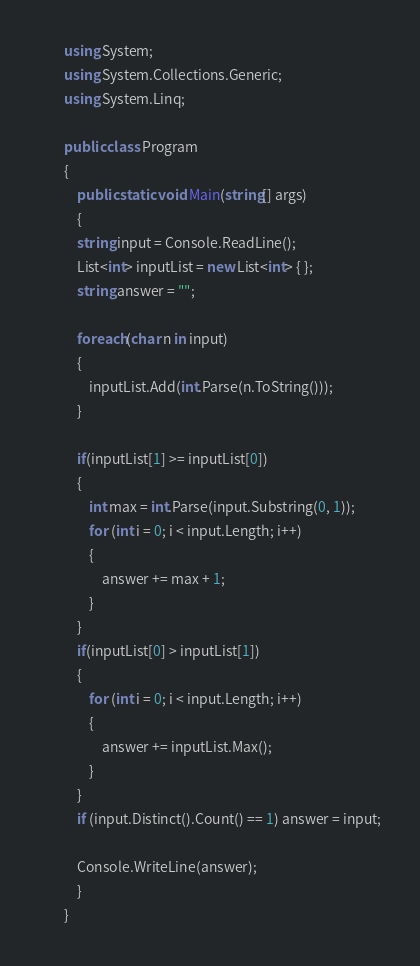Convert code to text. <code><loc_0><loc_0><loc_500><loc_500><_C#_>        using System;
        using System.Collections.Generic;
        using System.Linq;

        public class Program
        {
            public static void Main(string[] args)
            {
            string input = Console.ReadLine();
            List<int> inputList = new List<int> { };
            string answer = "";

            foreach(char n in input)
            {
                inputList.Add(int.Parse(n.ToString()));
            }

            if(inputList[1] >= inputList[0])
            {
                int max = int.Parse(input.Substring(0, 1));
                for (int i = 0; i < input.Length; i++)
                {
                    answer += max + 1;
                }
            }
            if(inputList[0] > inputList[1])
            {
                for (int i = 0; i < input.Length; i++)
                {
                    answer += inputList.Max();
                }
            }
            if (input.Distinct().Count() == 1) answer = input;

            Console.WriteLine(answer);
            }
        }</code> 